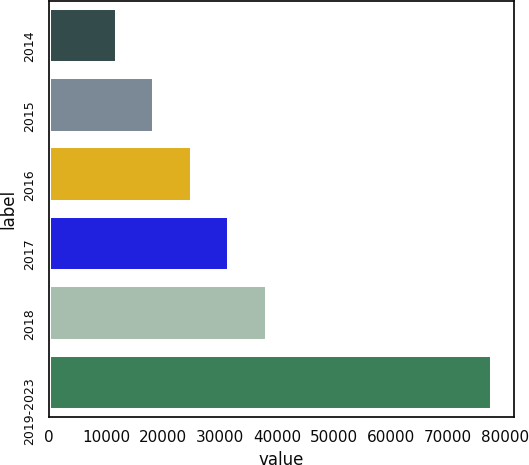Convert chart. <chart><loc_0><loc_0><loc_500><loc_500><bar_chart><fcel>2014<fcel>2015<fcel>2016<fcel>2017<fcel>2018<fcel>2019-2023<nl><fcel>11878<fcel>18463.8<fcel>25049.6<fcel>31635.4<fcel>38221.2<fcel>77736<nl></chart> 